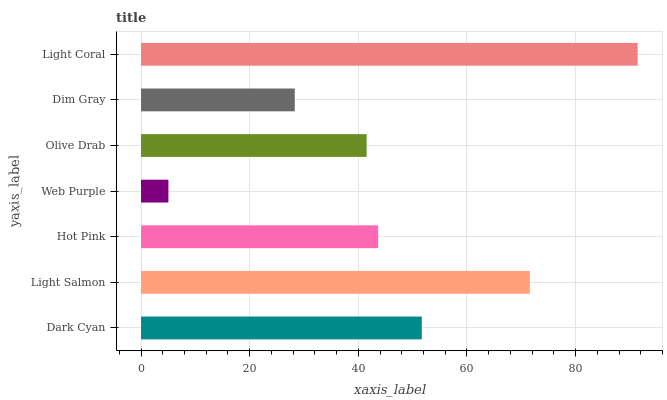Is Web Purple the minimum?
Answer yes or no. Yes. Is Light Coral the maximum?
Answer yes or no. Yes. Is Light Salmon the minimum?
Answer yes or no. No. Is Light Salmon the maximum?
Answer yes or no. No. Is Light Salmon greater than Dark Cyan?
Answer yes or no. Yes. Is Dark Cyan less than Light Salmon?
Answer yes or no. Yes. Is Dark Cyan greater than Light Salmon?
Answer yes or no. No. Is Light Salmon less than Dark Cyan?
Answer yes or no. No. Is Hot Pink the high median?
Answer yes or no. Yes. Is Hot Pink the low median?
Answer yes or no. Yes. Is Web Purple the high median?
Answer yes or no. No. Is Web Purple the low median?
Answer yes or no. No. 